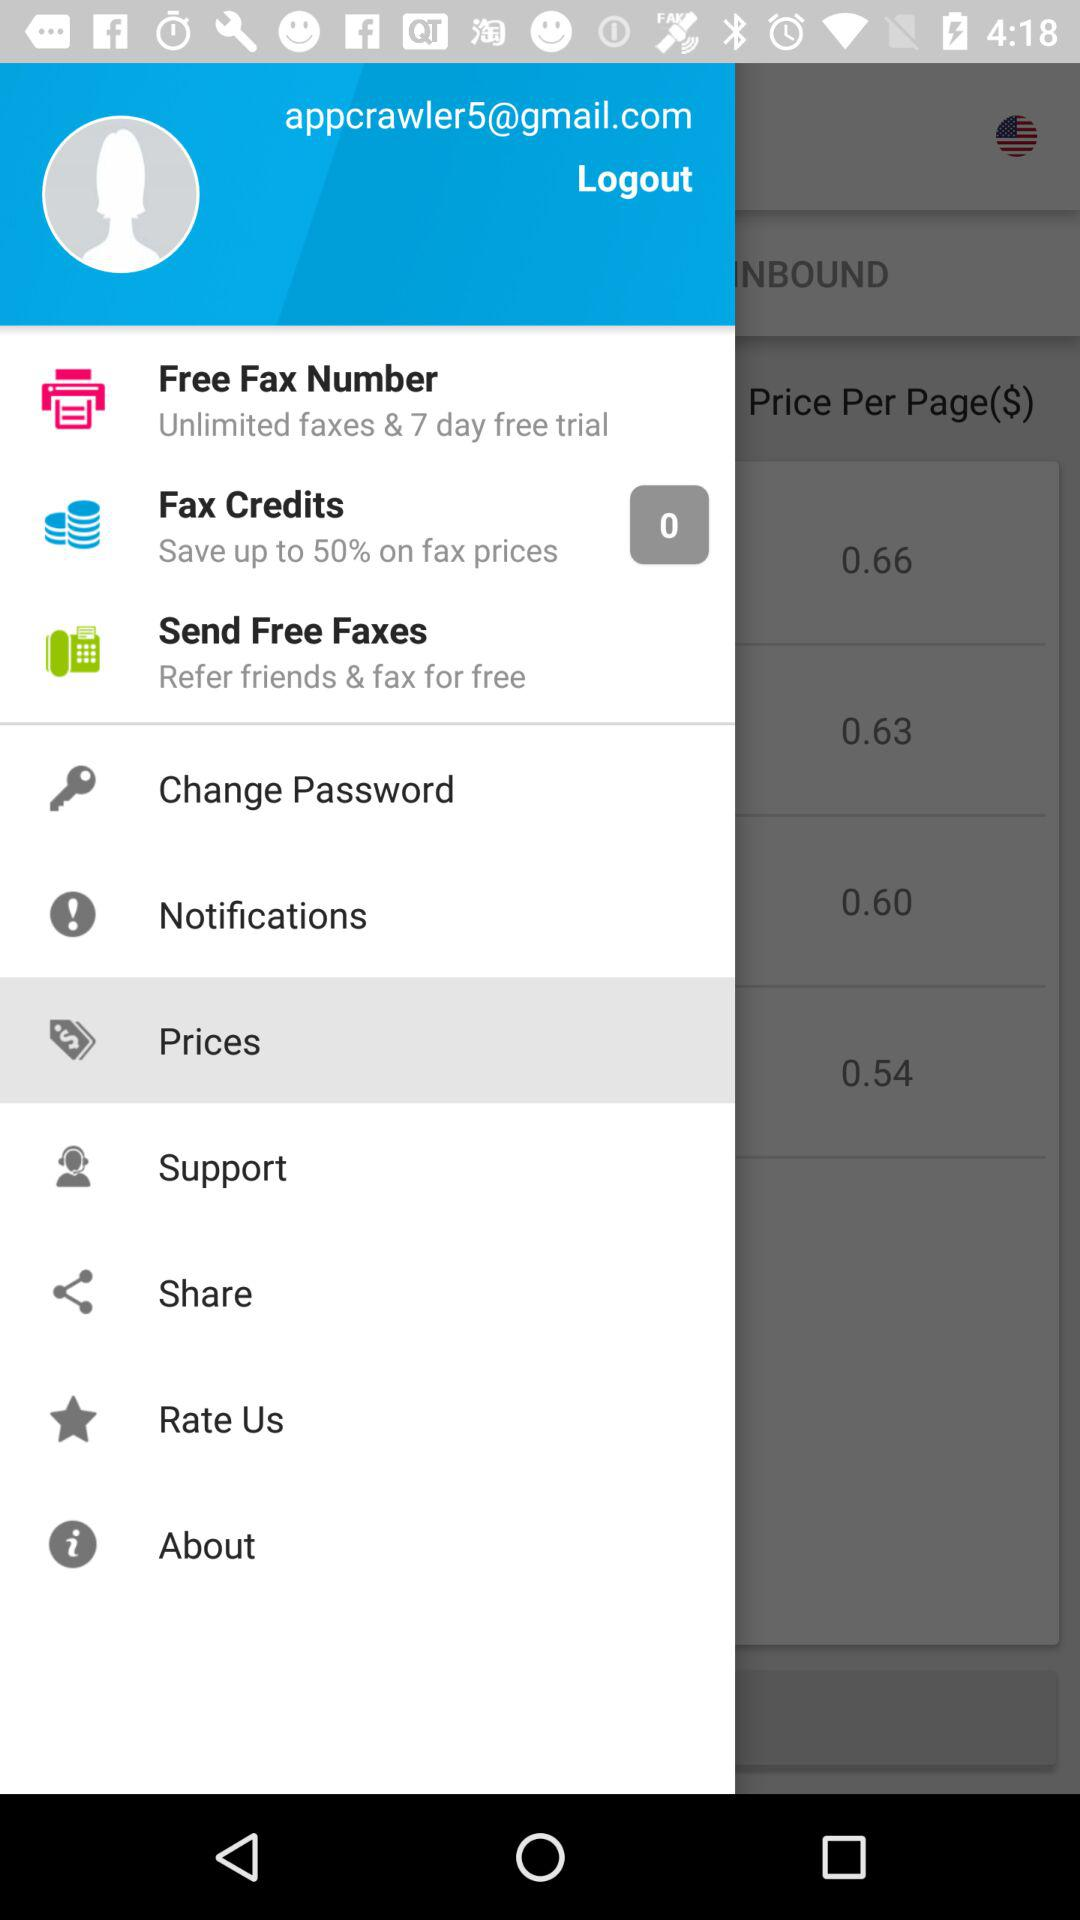How many fax credits are there? There are 0 fax credits. 